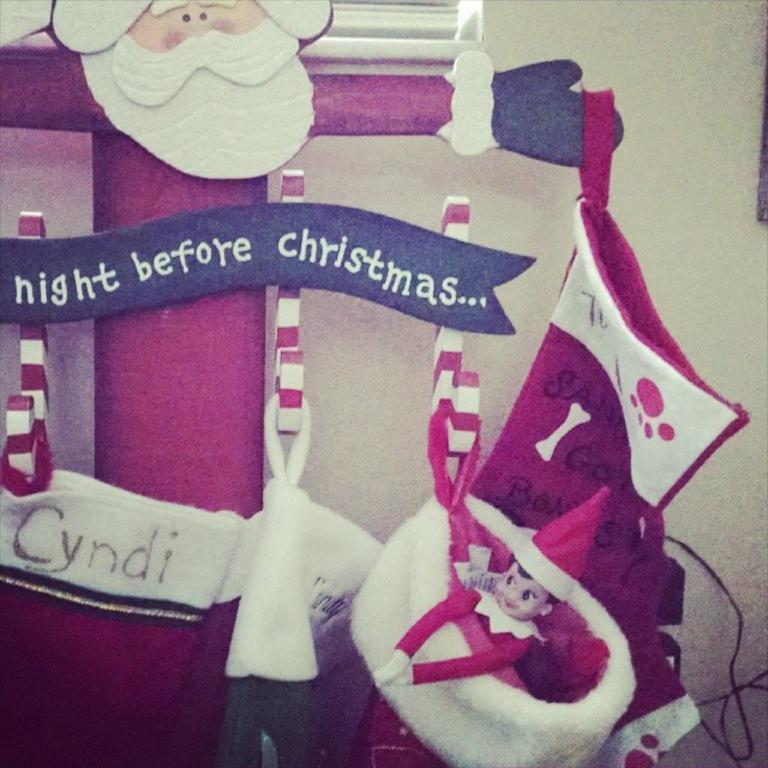What type of items can be seen in the image? There are toys, bags, wire, a name board, and hangers in the image. Can you describe the unspecified objects in the image? Unfortunately, the provided facts do not specify the nature of the unspecified objects. What is visible in the background of the image? There is a wall visible in the background of the image. Where is the sister in the image? There is no mention of a sister in the image or the provided facts. Can you describe the beetle crawling on the name board? There is no beetle present in the image. What type of sink is visible in the image? There is no sink present in the image. 